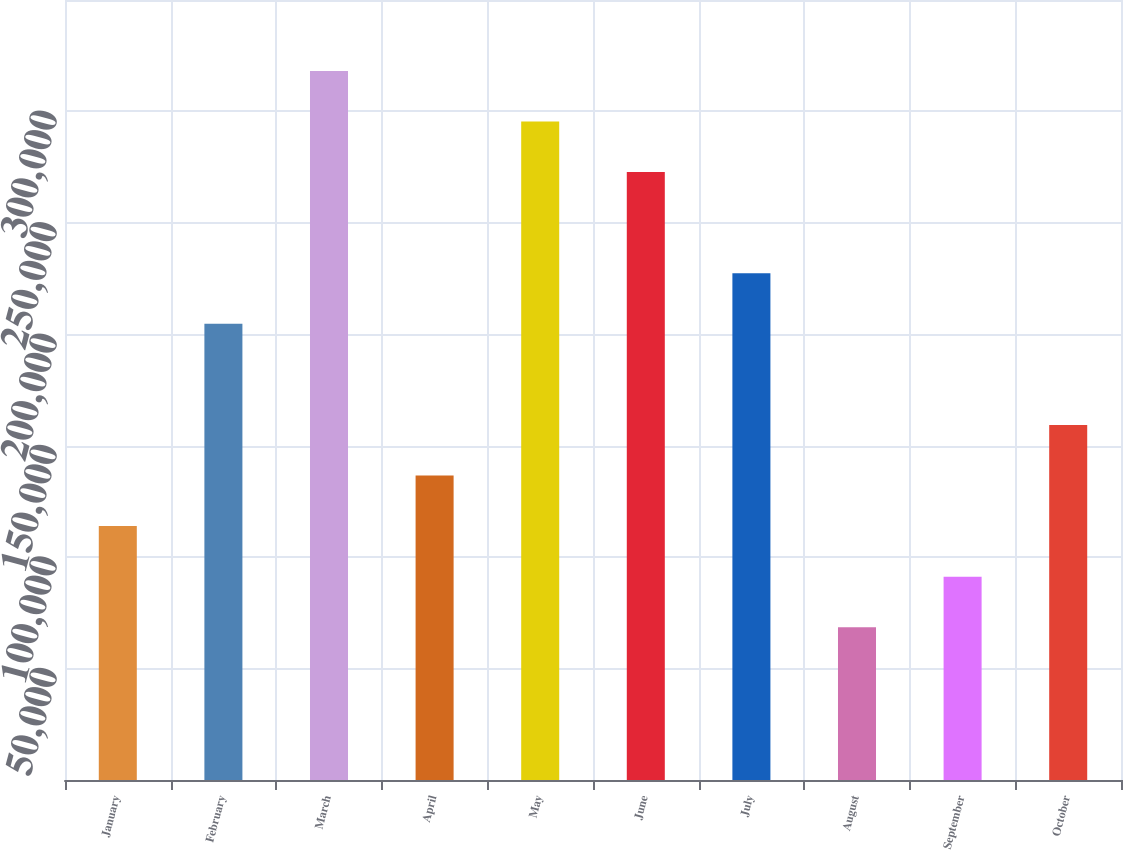<chart> <loc_0><loc_0><loc_500><loc_500><bar_chart><fcel>January<fcel>February<fcel>March<fcel>April<fcel>May<fcel>June<fcel>July<fcel>August<fcel>September<fcel>October<nl><fcel>113921<fcel>204692<fcel>318156<fcel>136614<fcel>295463<fcel>272770<fcel>227385<fcel>68536<fcel>91228.7<fcel>159307<nl></chart> 